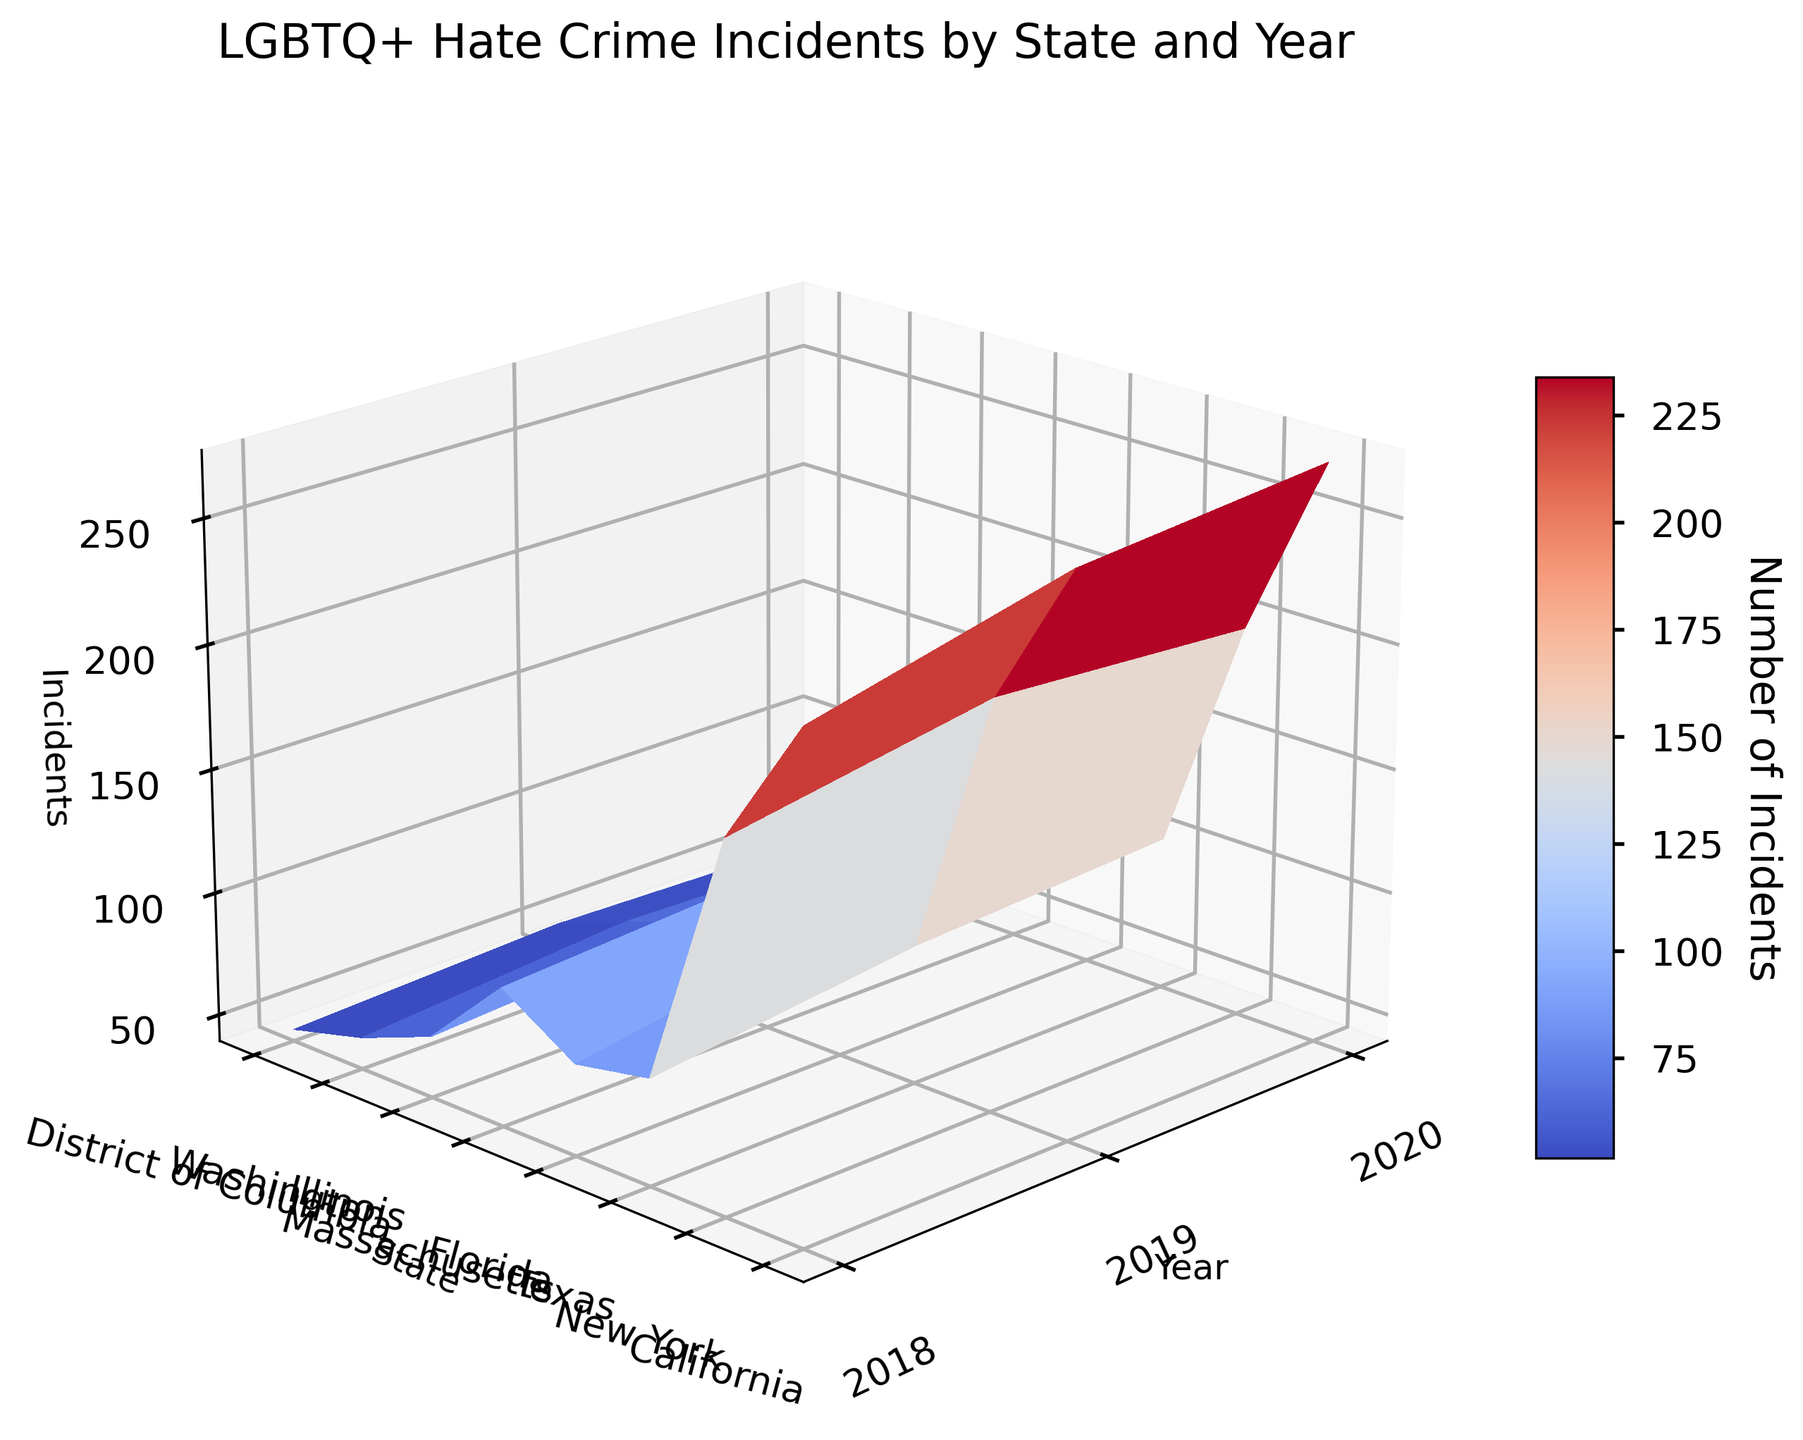What is the title of the plot? The title can be found at the top center of the plot. It should be visually distinct and descriptive of the data presented. The title here is "LGBTQ+ Hate Crime Incidents by State and Year".
Answer: LGBTQ+ Hate Crime Incidents by State and Year Which state had the highest number of incidents in 2020? Look for the highest point on the z-axis for the year 2020. California has the highest peak in 2020 with 272 incidents.
Answer: California How do the hate crime incidents in New York change from 2018 to 2020? Observe the data points for New York over the years from 2018 to 2020. Note the trend: in 2018 it's 186, then an increase to 204 in 2019, and a slight decrease to 197 in 2020.
Answer: Increase, then slight decrease Which state shows the least variation in incident numbers over the three years? Compare the fluctuation in data points of each state over the three years. Illinois shows minor variation: 64 in 2018, 71 in 2019, and 69 in 2020.
Answer: Illinois What is the average number of incidents in California from 2018 to 2020? Calculate the average by summing the incidents for California and then divide by the number of years: (238 + 263 + 272) / 3 = 773 / 3 = 257.67.
Answer: 257.67 What is the total number of incidents reported in 2019 for all states combined? Sum up the incidents from all states for the year 2019. California: 263, New York: 204, Texas: 95, Florida: 93, Massachusetts: 102, Illinois: 71, Washington: 61, DC: 49. Total: 263 + 204 + 95 + 93 + 102 + 71 + 61 + 49 = 938.
Answer: 938 Which state had a decline in incidents from 2019 to 2020? Compare the 2019 and 2020 data points for each state. New York had a decline from 204 in 2019 to 197 in 2020.
Answer: New York How does the number of incidents in Texas in 2020 compare to the incidents in Florida in 2019? Refer to the respective data points: Texas in 2020 has 101 incidents, and Florida in 2019 has 93. Texas has more incidents than Florida in these years.
Answer: Texas has more What is the color scale used to represent the number of incidents? Identify the color gradient of the plot, which is used to represent different values of incidents. The color scale ranges from cool (blue) to warm (red) colors.
Answer: Cool to warm (blue to red) How does the elevation angle affect the visibility of the 3D surface plot? Changing the elevation angle alters the way the surface plot is viewed, allowing clearer visualization of some peaks and troughs not easily visible from the default angle. It can be seen in the image that the view is initially set with an elevation of 20 and an azimuth of 225 degrees.
Answer: Changing the angle alters visibility 